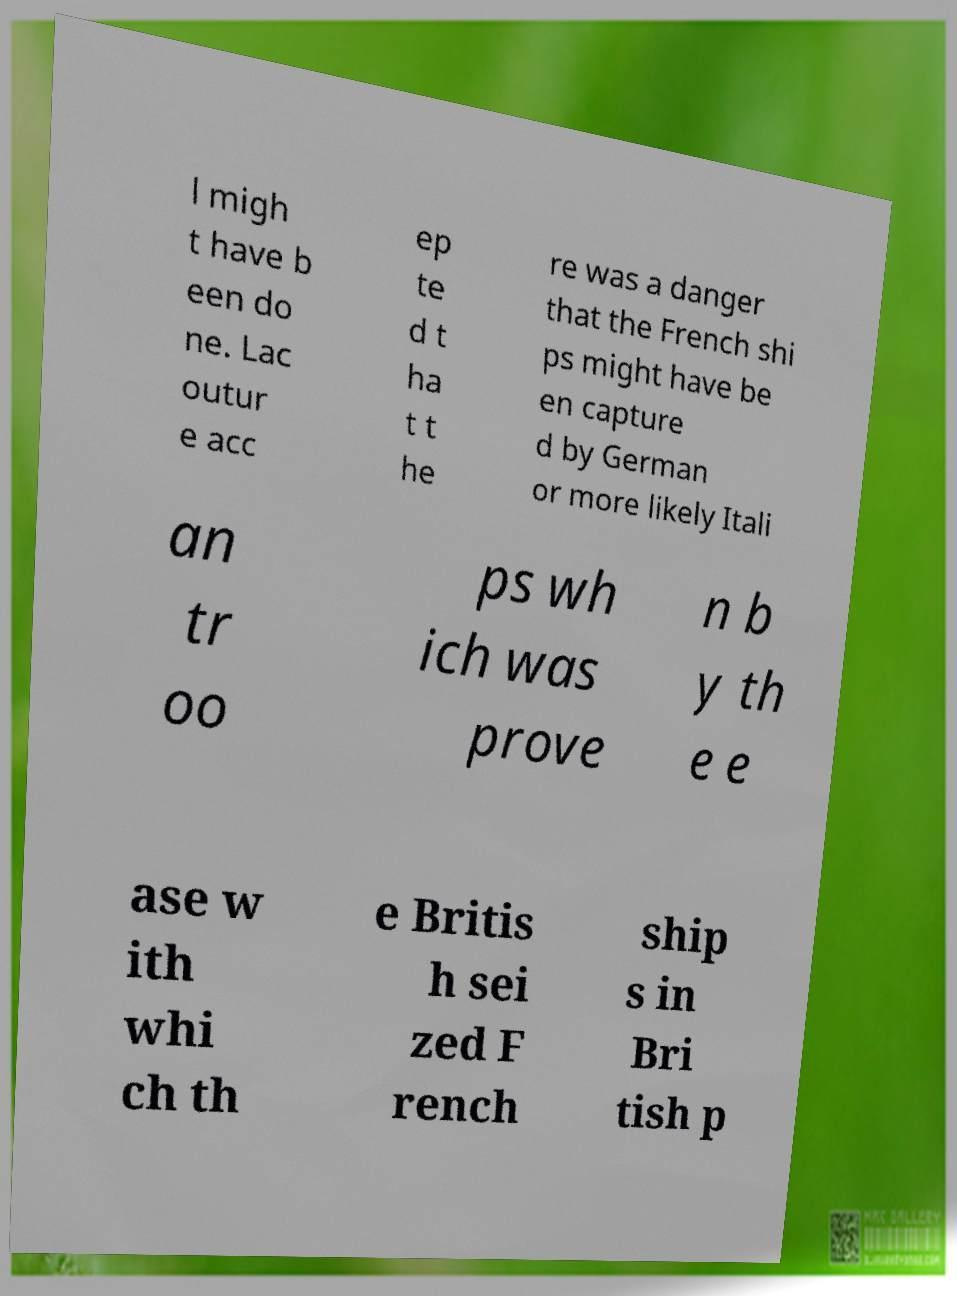Could you assist in decoding the text presented in this image and type it out clearly? l migh t have b een do ne. Lac outur e acc ep te d t ha t t he re was a danger that the French shi ps might have be en capture d by German or more likely Itali an tr oo ps wh ich was prove n b y th e e ase w ith whi ch th e Britis h sei zed F rench ship s in Bri tish p 